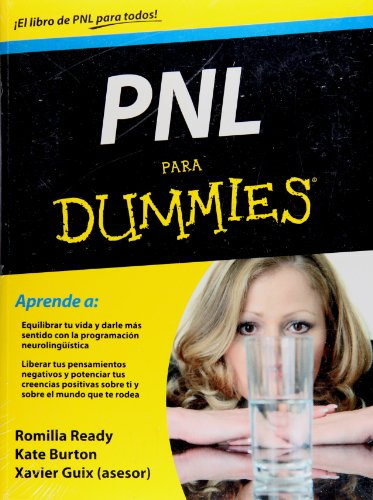Who is the author of this book? This book is co-authored by Romilla Ready and Kate Burton, with Xavier Guix acting as an advisor, which illustrates a collaborative effort to bring this self-help guide to readers. 